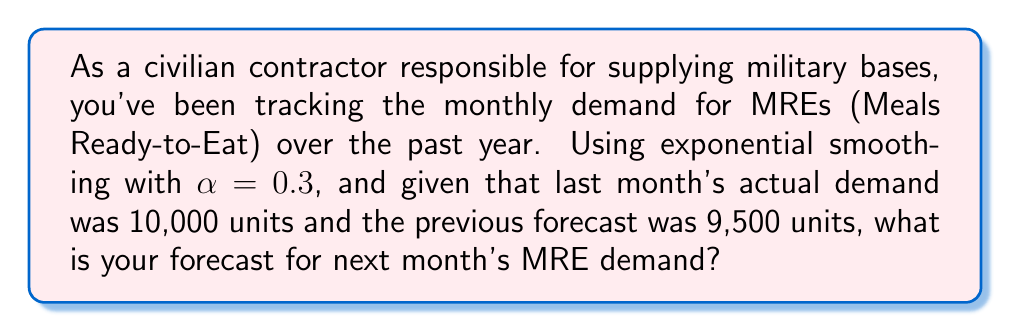Solve this math problem. To solve this problem, we'll use the exponential smoothing formula:

$$F_t = \alpha D_{t-1} + (1-\alpha)F_{t-1}$$

Where:
$F_t$ is the forecast for the current period
$\alpha$ is the smoothing constant (0.3 in this case)
$D_{t-1}$ is the actual demand for the previous period (10,000 units)
$F_{t-1}$ is the previous period's forecast (9,500 units)

Let's substitute these values into the formula:

$$F_t = 0.3 \times 10,000 + (1-0.3) \times 9,500$$

Simplifying:

$$F_t = 3,000 + 0.7 \times 9,500$$
$$F_t = 3,000 + 6,650$$
$$F_t = 9,650$$

Therefore, the forecast for next month's MRE demand is 9,650 units.
Answer: 9,650 units 